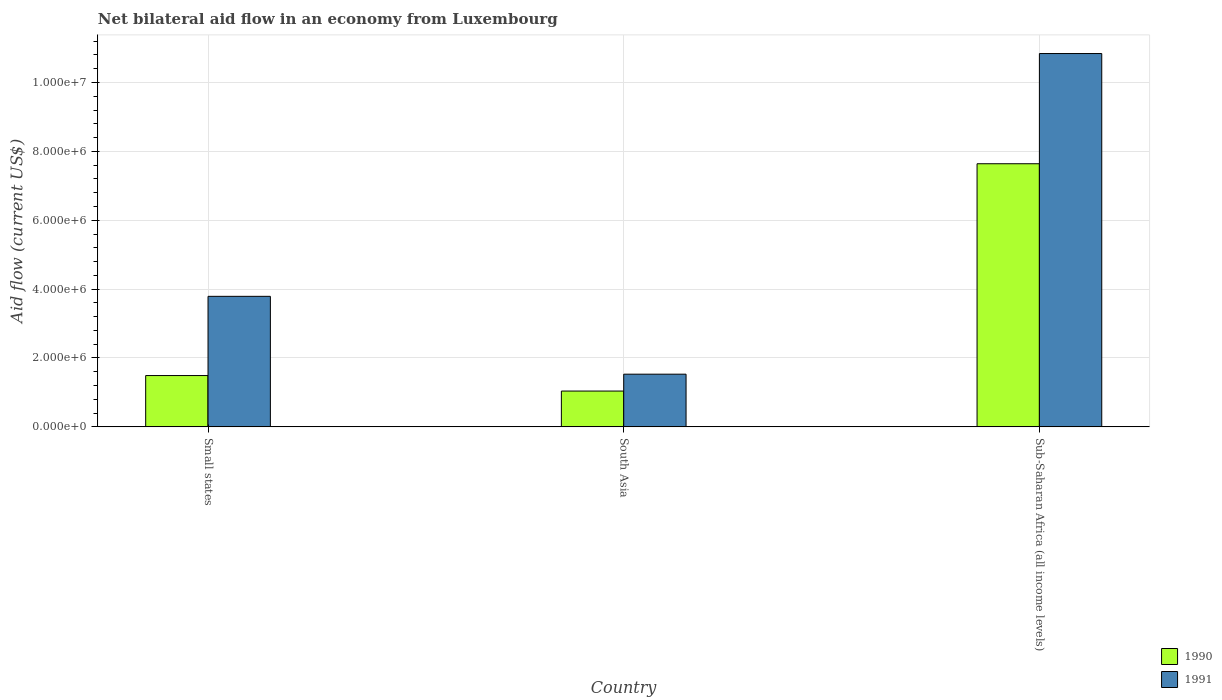How many different coloured bars are there?
Provide a succinct answer. 2. How many groups of bars are there?
Offer a terse response. 3. Are the number of bars per tick equal to the number of legend labels?
Your answer should be compact. Yes. Are the number of bars on each tick of the X-axis equal?
Your answer should be compact. Yes. How many bars are there on the 1st tick from the left?
Make the answer very short. 2. How many bars are there on the 3rd tick from the right?
Your answer should be very brief. 2. What is the net bilateral aid flow in 1991 in Sub-Saharan Africa (all income levels)?
Your answer should be very brief. 1.08e+07. Across all countries, what is the maximum net bilateral aid flow in 1991?
Provide a short and direct response. 1.08e+07. Across all countries, what is the minimum net bilateral aid flow in 1991?
Provide a short and direct response. 1.53e+06. In which country was the net bilateral aid flow in 1990 maximum?
Make the answer very short. Sub-Saharan Africa (all income levels). In which country was the net bilateral aid flow in 1991 minimum?
Your answer should be very brief. South Asia. What is the total net bilateral aid flow in 1990 in the graph?
Your response must be concise. 1.02e+07. What is the difference between the net bilateral aid flow in 1991 in Small states and that in South Asia?
Make the answer very short. 2.26e+06. What is the difference between the net bilateral aid flow in 1990 in South Asia and the net bilateral aid flow in 1991 in Small states?
Make the answer very short. -2.75e+06. What is the average net bilateral aid flow in 1990 per country?
Provide a succinct answer. 3.39e+06. What is the difference between the net bilateral aid flow of/in 1991 and net bilateral aid flow of/in 1990 in Small states?
Provide a succinct answer. 2.30e+06. What is the ratio of the net bilateral aid flow in 1990 in South Asia to that in Sub-Saharan Africa (all income levels)?
Make the answer very short. 0.14. Is the net bilateral aid flow in 1991 in Small states less than that in South Asia?
Ensure brevity in your answer.  No. Is the difference between the net bilateral aid flow in 1991 in Small states and Sub-Saharan Africa (all income levels) greater than the difference between the net bilateral aid flow in 1990 in Small states and Sub-Saharan Africa (all income levels)?
Your answer should be compact. No. What is the difference between the highest and the second highest net bilateral aid flow in 1991?
Make the answer very short. 9.31e+06. What is the difference between the highest and the lowest net bilateral aid flow in 1991?
Your response must be concise. 9.31e+06. In how many countries, is the net bilateral aid flow in 1990 greater than the average net bilateral aid flow in 1990 taken over all countries?
Make the answer very short. 1. Is the sum of the net bilateral aid flow in 1990 in South Asia and Sub-Saharan Africa (all income levels) greater than the maximum net bilateral aid flow in 1991 across all countries?
Offer a terse response. No. What does the 1st bar from the left in Small states represents?
Your answer should be very brief. 1990. How many bars are there?
Your answer should be very brief. 6. Are all the bars in the graph horizontal?
Ensure brevity in your answer.  No. Are the values on the major ticks of Y-axis written in scientific E-notation?
Your response must be concise. Yes. Does the graph contain any zero values?
Keep it short and to the point. No. How many legend labels are there?
Provide a succinct answer. 2. What is the title of the graph?
Provide a short and direct response. Net bilateral aid flow in an economy from Luxembourg. What is the Aid flow (current US$) of 1990 in Small states?
Make the answer very short. 1.49e+06. What is the Aid flow (current US$) of 1991 in Small states?
Your answer should be very brief. 3.79e+06. What is the Aid flow (current US$) in 1990 in South Asia?
Ensure brevity in your answer.  1.04e+06. What is the Aid flow (current US$) in 1991 in South Asia?
Give a very brief answer. 1.53e+06. What is the Aid flow (current US$) in 1990 in Sub-Saharan Africa (all income levels)?
Your answer should be compact. 7.64e+06. What is the Aid flow (current US$) in 1991 in Sub-Saharan Africa (all income levels)?
Offer a very short reply. 1.08e+07. Across all countries, what is the maximum Aid flow (current US$) of 1990?
Your answer should be compact. 7.64e+06. Across all countries, what is the maximum Aid flow (current US$) of 1991?
Your answer should be very brief. 1.08e+07. Across all countries, what is the minimum Aid flow (current US$) of 1990?
Ensure brevity in your answer.  1.04e+06. Across all countries, what is the minimum Aid flow (current US$) of 1991?
Provide a succinct answer. 1.53e+06. What is the total Aid flow (current US$) in 1990 in the graph?
Your answer should be very brief. 1.02e+07. What is the total Aid flow (current US$) of 1991 in the graph?
Provide a short and direct response. 1.62e+07. What is the difference between the Aid flow (current US$) of 1990 in Small states and that in South Asia?
Provide a succinct answer. 4.50e+05. What is the difference between the Aid flow (current US$) in 1991 in Small states and that in South Asia?
Provide a short and direct response. 2.26e+06. What is the difference between the Aid flow (current US$) in 1990 in Small states and that in Sub-Saharan Africa (all income levels)?
Ensure brevity in your answer.  -6.15e+06. What is the difference between the Aid flow (current US$) in 1991 in Small states and that in Sub-Saharan Africa (all income levels)?
Ensure brevity in your answer.  -7.05e+06. What is the difference between the Aid flow (current US$) in 1990 in South Asia and that in Sub-Saharan Africa (all income levels)?
Keep it short and to the point. -6.60e+06. What is the difference between the Aid flow (current US$) in 1991 in South Asia and that in Sub-Saharan Africa (all income levels)?
Ensure brevity in your answer.  -9.31e+06. What is the difference between the Aid flow (current US$) of 1990 in Small states and the Aid flow (current US$) of 1991 in Sub-Saharan Africa (all income levels)?
Provide a short and direct response. -9.35e+06. What is the difference between the Aid flow (current US$) in 1990 in South Asia and the Aid flow (current US$) in 1991 in Sub-Saharan Africa (all income levels)?
Give a very brief answer. -9.80e+06. What is the average Aid flow (current US$) of 1990 per country?
Keep it short and to the point. 3.39e+06. What is the average Aid flow (current US$) in 1991 per country?
Offer a very short reply. 5.39e+06. What is the difference between the Aid flow (current US$) of 1990 and Aid flow (current US$) of 1991 in Small states?
Offer a terse response. -2.30e+06. What is the difference between the Aid flow (current US$) in 1990 and Aid flow (current US$) in 1991 in South Asia?
Your answer should be compact. -4.90e+05. What is the difference between the Aid flow (current US$) of 1990 and Aid flow (current US$) of 1991 in Sub-Saharan Africa (all income levels)?
Your answer should be very brief. -3.20e+06. What is the ratio of the Aid flow (current US$) in 1990 in Small states to that in South Asia?
Your response must be concise. 1.43. What is the ratio of the Aid flow (current US$) in 1991 in Small states to that in South Asia?
Your response must be concise. 2.48. What is the ratio of the Aid flow (current US$) of 1990 in Small states to that in Sub-Saharan Africa (all income levels)?
Make the answer very short. 0.2. What is the ratio of the Aid flow (current US$) in 1991 in Small states to that in Sub-Saharan Africa (all income levels)?
Provide a short and direct response. 0.35. What is the ratio of the Aid flow (current US$) of 1990 in South Asia to that in Sub-Saharan Africa (all income levels)?
Keep it short and to the point. 0.14. What is the ratio of the Aid flow (current US$) in 1991 in South Asia to that in Sub-Saharan Africa (all income levels)?
Your response must be concise. 0.14. What is the difference between the highest and the second highest Aid flow (current US$) in 1990?
Offer a terse response. 6.15e+06. What is the difference between the highest and the second highest Aid flow (current US$) of 1991?
Make the answer very short. 7.05e+06. What is the difference between the highest and the lowest Aid flow (current US$) in 1990?
Your answer should be very brief. 6.60e+06. What is the difference between the highest and the lowest Aid flow (current US$) in 1991?
Make the answer very short. 9.31e+06. 